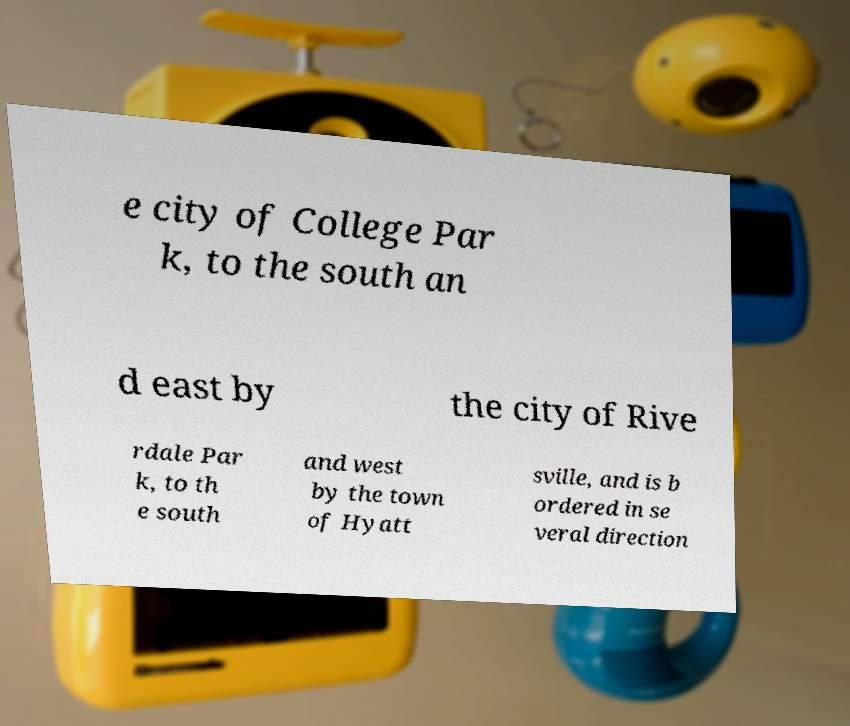Could you assist in decoding the text presented in this image and type it out clearly? e city of College Par k, to the south an d east by the city of Rive rdale Par k, to th e south and west by the town of Hyatt sville, and is b ordered in se veral direction 